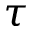Convert formula to latex. <formula><loc_0><loc_0><loc_500><loc_500>\boldsymbol \tau</formula> 